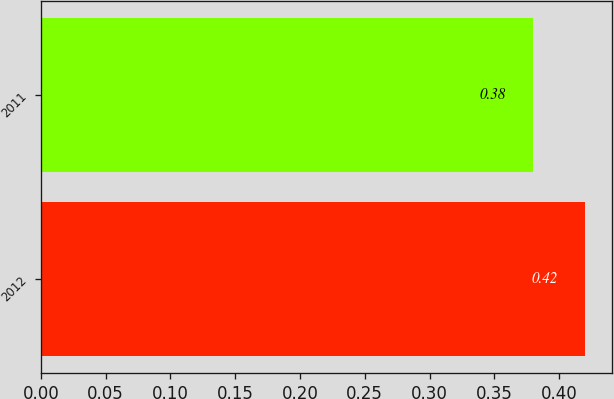<chart> <loc_0><loc_0><loc_500><loc_500><bar_chart><fcel>2012<fcel>2011<nl><fcel>0.42<fcel>0.38<nl></chart> 